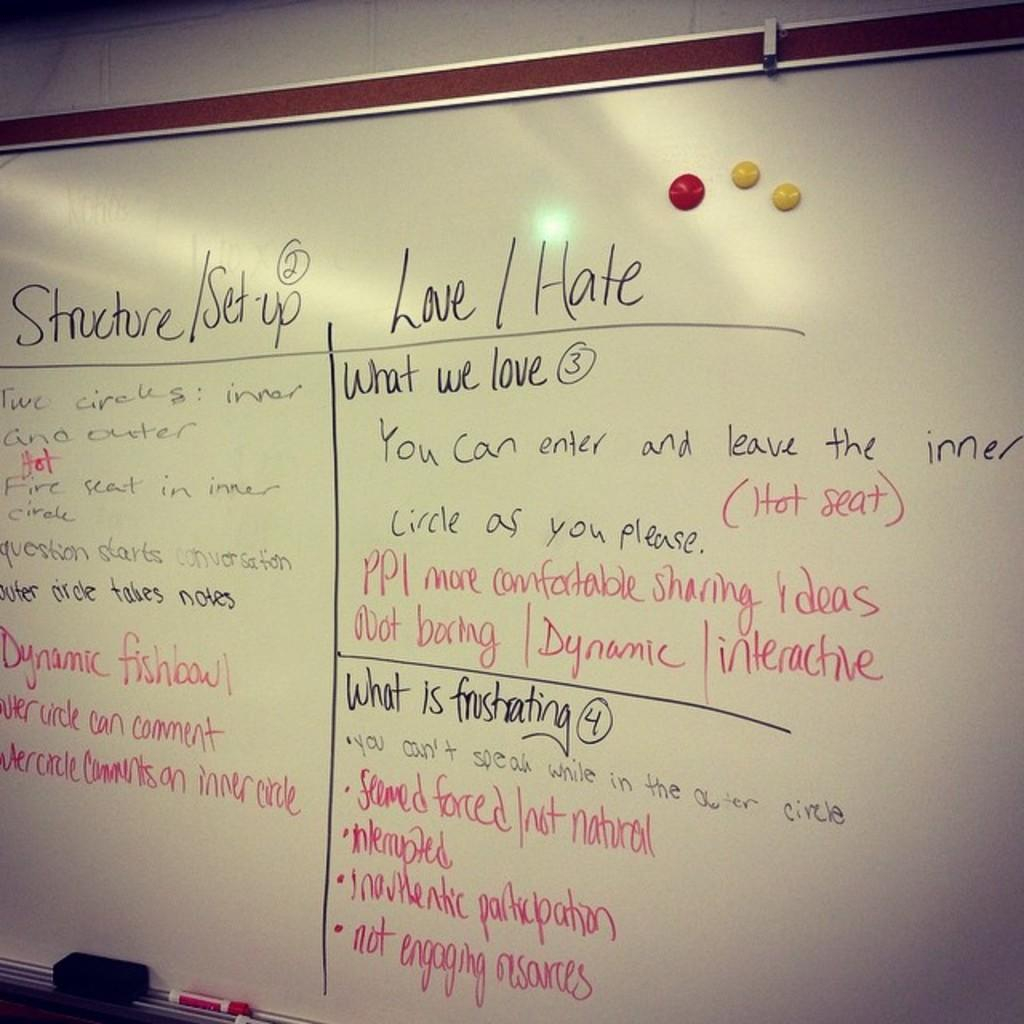<image>
Offer a succinct explanation of the picture presented. A classroom discussion of the structure and set up, what they love and hate about the topic, and what's frustrating to them. 